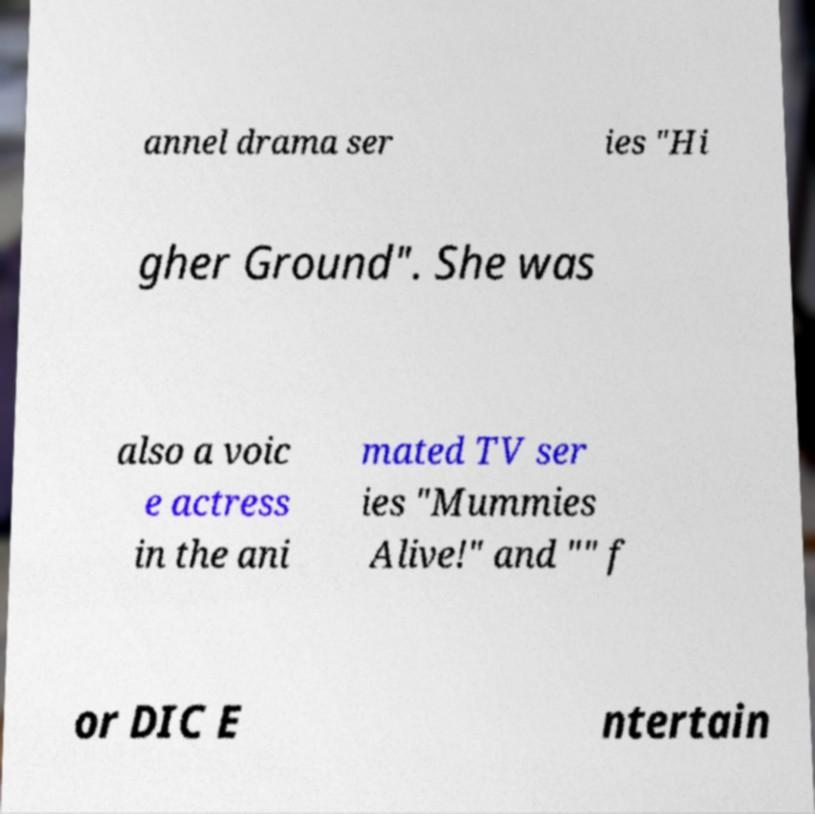Could you assist in decoding the text presented in this image and type it out clearly? annel drama ser ies "Hi gher Ground". She was also a voic e actress in the ani mated TV ser ies "Mummies Alive!" and "" f or DIC E ntertain 